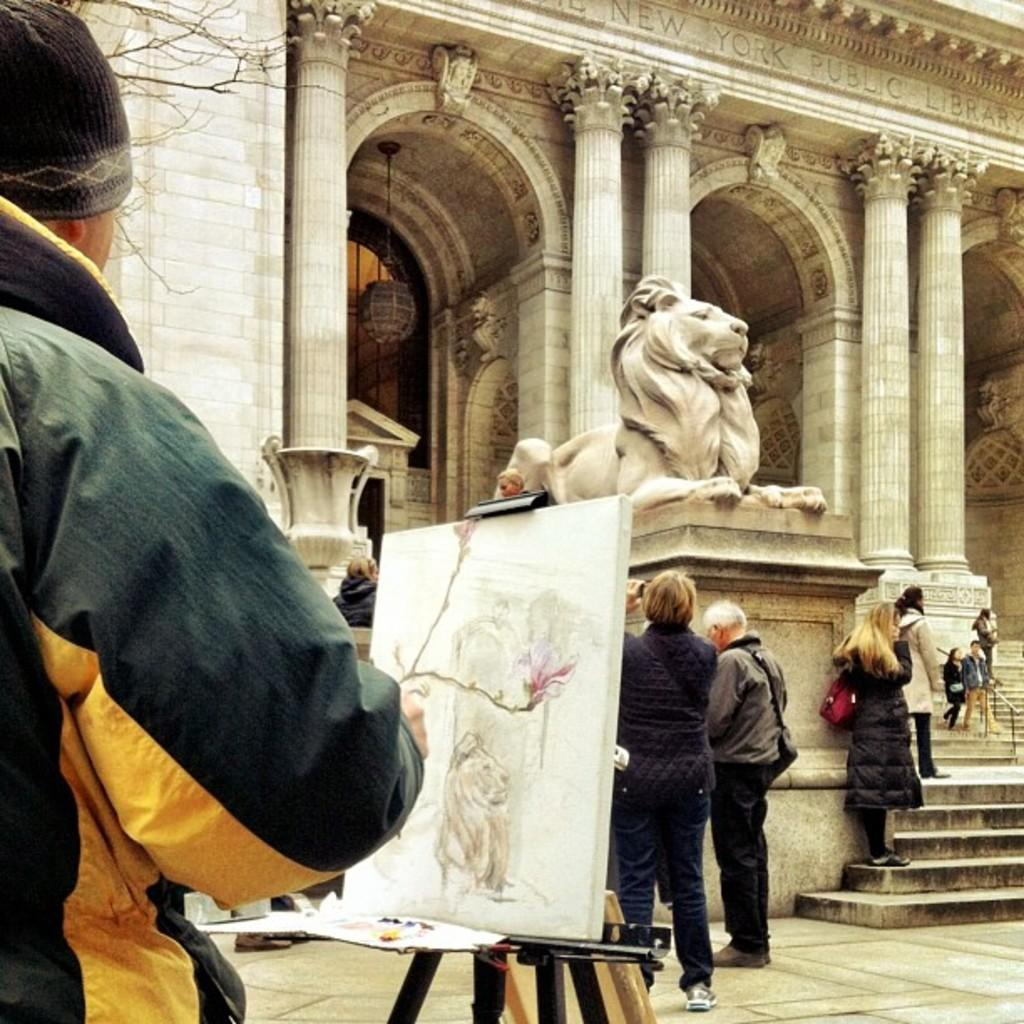What is the position of the person in the image? There is a person standing on the left side of the image. What is the person looking at or interacting with in the image? The person is standing in front of a drawing on a board. What is the background of the image? There is a building in front of the person, and there are people and pillars in front of the building. What is the statue's location in the image? There is a statue in front of the building. What type of love can be seen between the sheep in the image? There are no sheep present in the image, so it is not possible to determine the type of love between them. 